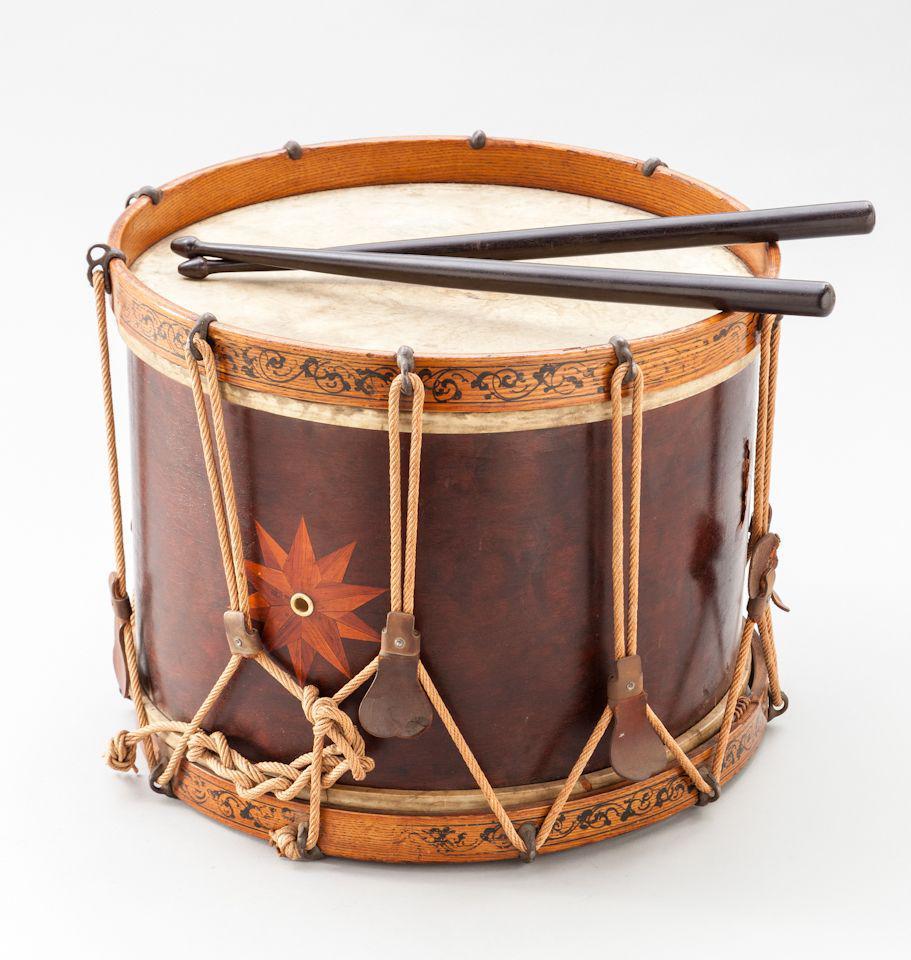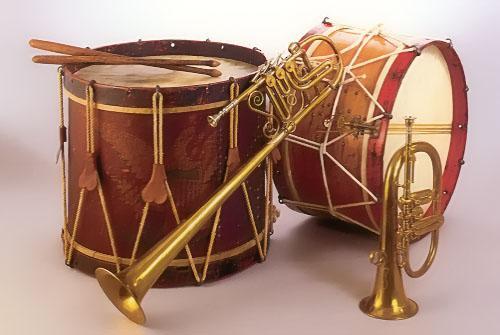The first image is the image on the left, the second image is the image on the right. Analyze the images presented: Is the assertion "There is more than one type of instrument." valid? Answer yes or no. Yes. The first image is the image on the left, the second image is the image on the right. Examine the images to the left and right. Is the description "One image shows a single drum while the other shows drums along with other types of instruments." accurate? Answer yes or no. Yes. 